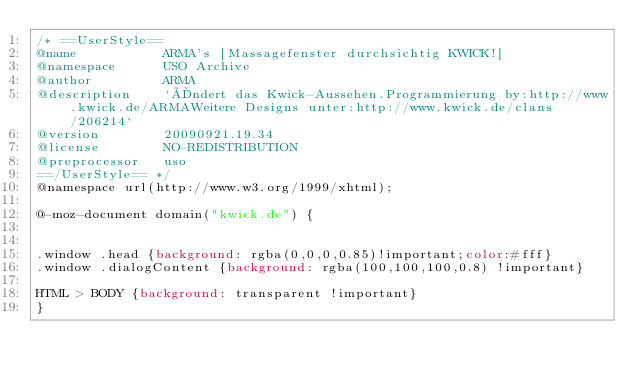<code> <loc_0><loc_0><loc_500><loc_500><_CSS_>/* ==UserStyle==
@name           ARMA's [Massagefenster durchsichtig KWICK!]
@namespace      USO Archive
@author         ARMA
@description    `Ändert das Kwick-Aussehen.Programmierung by:http://www.kwick.de/ARMAWeitere Designs unter:http://www.kwick.de/clans/206214`
@version        20090921.19.34
@license        NO-REDISTRIBUTION
@preprocessor   uso
==/UserStyle== */
@namespace url(http://www.w3.org/1999/xhtml);

@-moz-document domain("kwick.de") {


.window .head {background: rgba(0,0,0,0.85)!important;color:#fff}
.window .dialogContent {background: rgba(100,100,100,0.8) !important}

HTML > BODY {background: transparent !important}
}</code> 